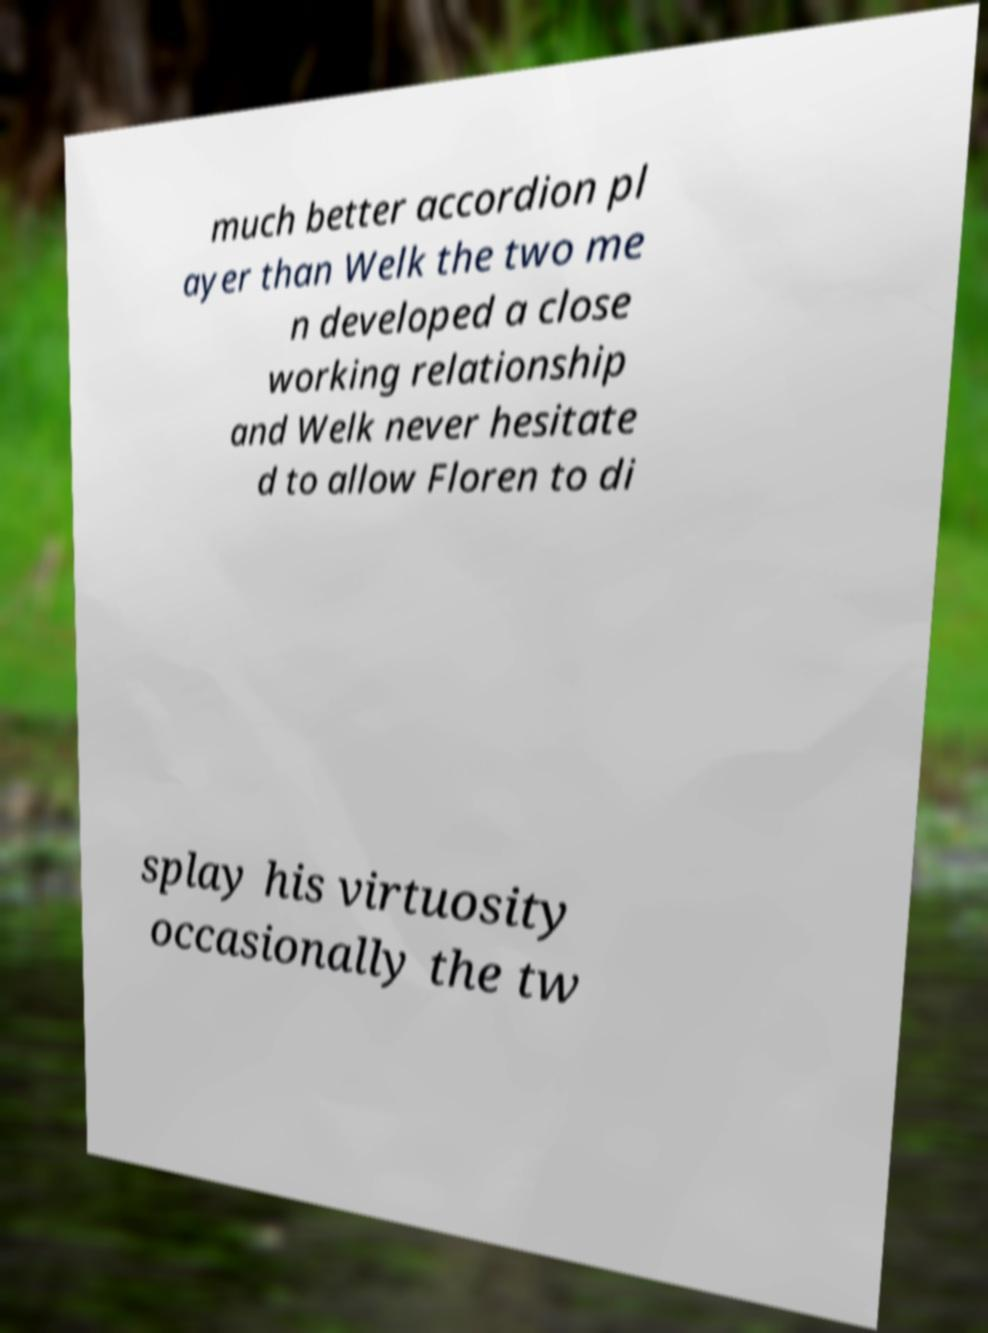What messages or text are displayed in this image? I need them in a readable, typed format. much better accordion pl ayer than Welk the two me n developed a close working relationship and Welk never hesitate d to allow Floren to di splay his virtuosity occasionally the tw 